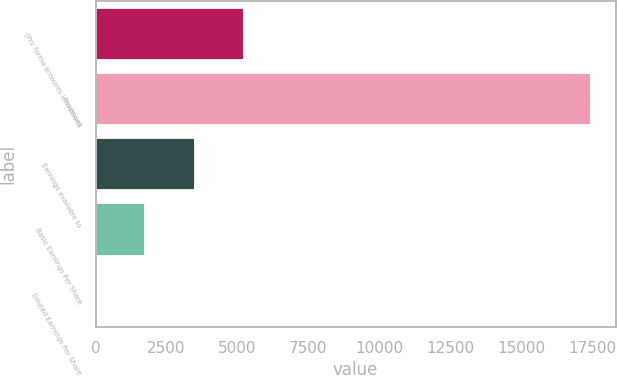<chart> <loc_0><loc_0><loc_500><loc_500><bar_chart><fcel>(Pro forma amounts in millions<fcel>Revenues<fcel>Earnings available to<fcel>Basic Earnings Per Share<fcel>Diluted Earnings Per Share<nl><fcel>5236.34<fcel>17449<fcel>3491.67<fcel>1747<fcel>2.33<nl></chart> 